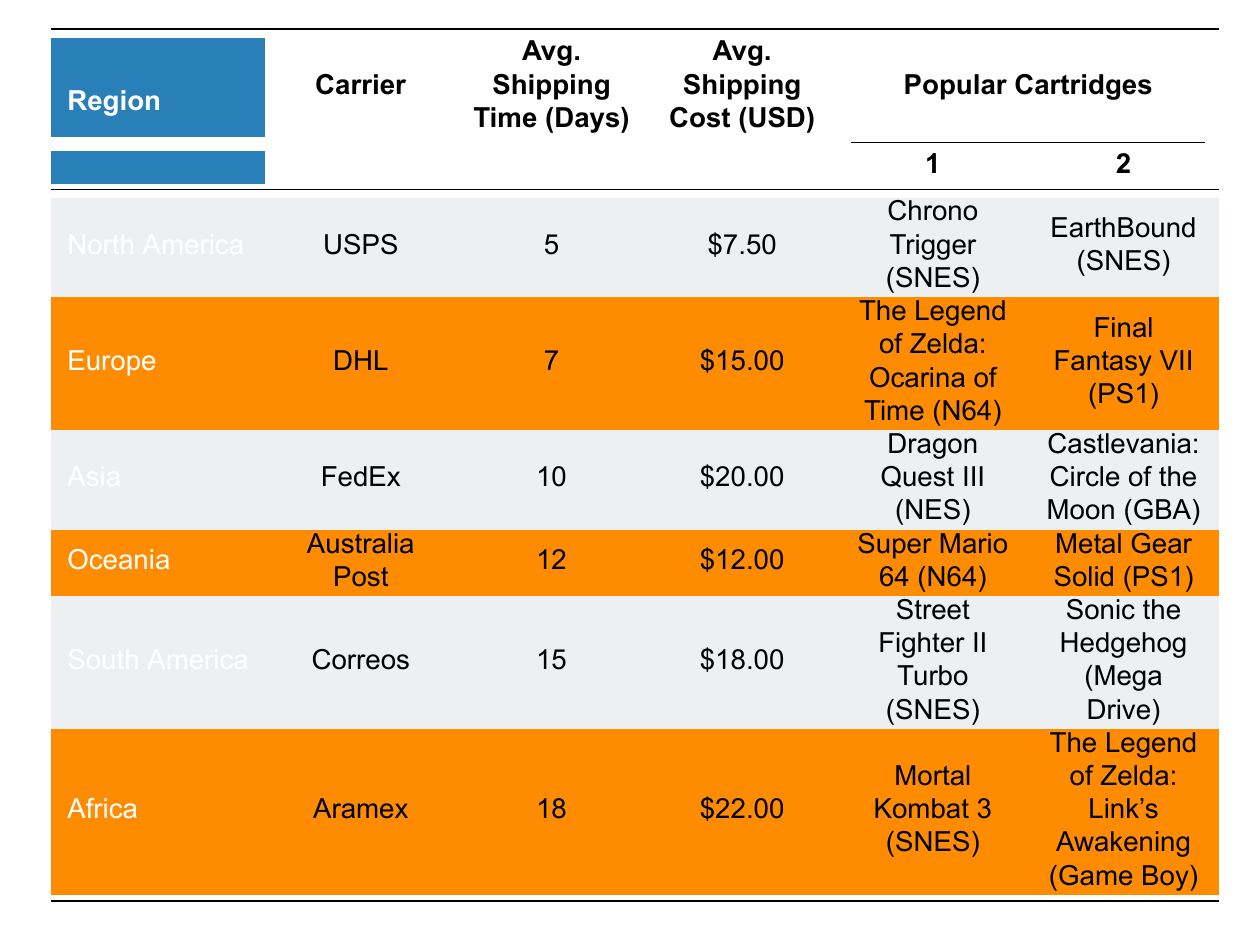What is the average shipping time for North America? The table lists the average shipping time for North America under the "Avg. Shipping Time (Days)" column, which is 5 days.
Answer: 5 days How much does shipping cost to Europe? The average shipping cost for Europe is found in the "Avg. Shipping Cost (USD)" column, which shows it as 15.00 USD.
Answer: 15.00 USD Which region has the longest average shipping time? By comparing the "Avg. Shipping Time (Days)" values across all regions, South America has the longest time listed at 15 days.
Answer: South America Is the shipping cost to Asia higher than to Europe? The shipping cost to Asia is 20.00 USD and to Europe is 15.00 USD. Since 20.00 is greater than 15.00, the answer is yes.
Answer: Yes What is the average shipping cost for the regions listed in the table? To find the average shipping cost, I sum the costs (7.50 + 15.00 + 20.00 + 12.00 + 18.00 + 22.00) which equals 94.50 USD. Dividing by the number of regions (6), the average cost is 15.75 USD.
Answer: 15.75 USD Which region uses USPS as the carrier? The table indicates that North America is the region using USPS under the "Carrier" column.
Answer: North America Does Oceania have a cheaper shipping cost than South America? The average shipping cost for Oceania is 12.00 USD, while for South America it is 18.00 USD. Since 12.00 is less than 18.00, Oceania has a cheaper cost.
Answer: Yes How many days longer does shipping take to Africa compared to North America? Shipping to Africa takes 18 days and to North America takes 5 days. The difference is 18 - 5 = 13 days longer.
Answer: 13 days What popular cartridge is shipped from Asia? The table lists "Dragon Quest III (NES)" and "Castlevania: Circle of the Moon (GBA)" as popular cartridges shipped from Asia.
Answer: Dragon Quest III (NES), Castlevania: Circle of the Moon (GBA) 